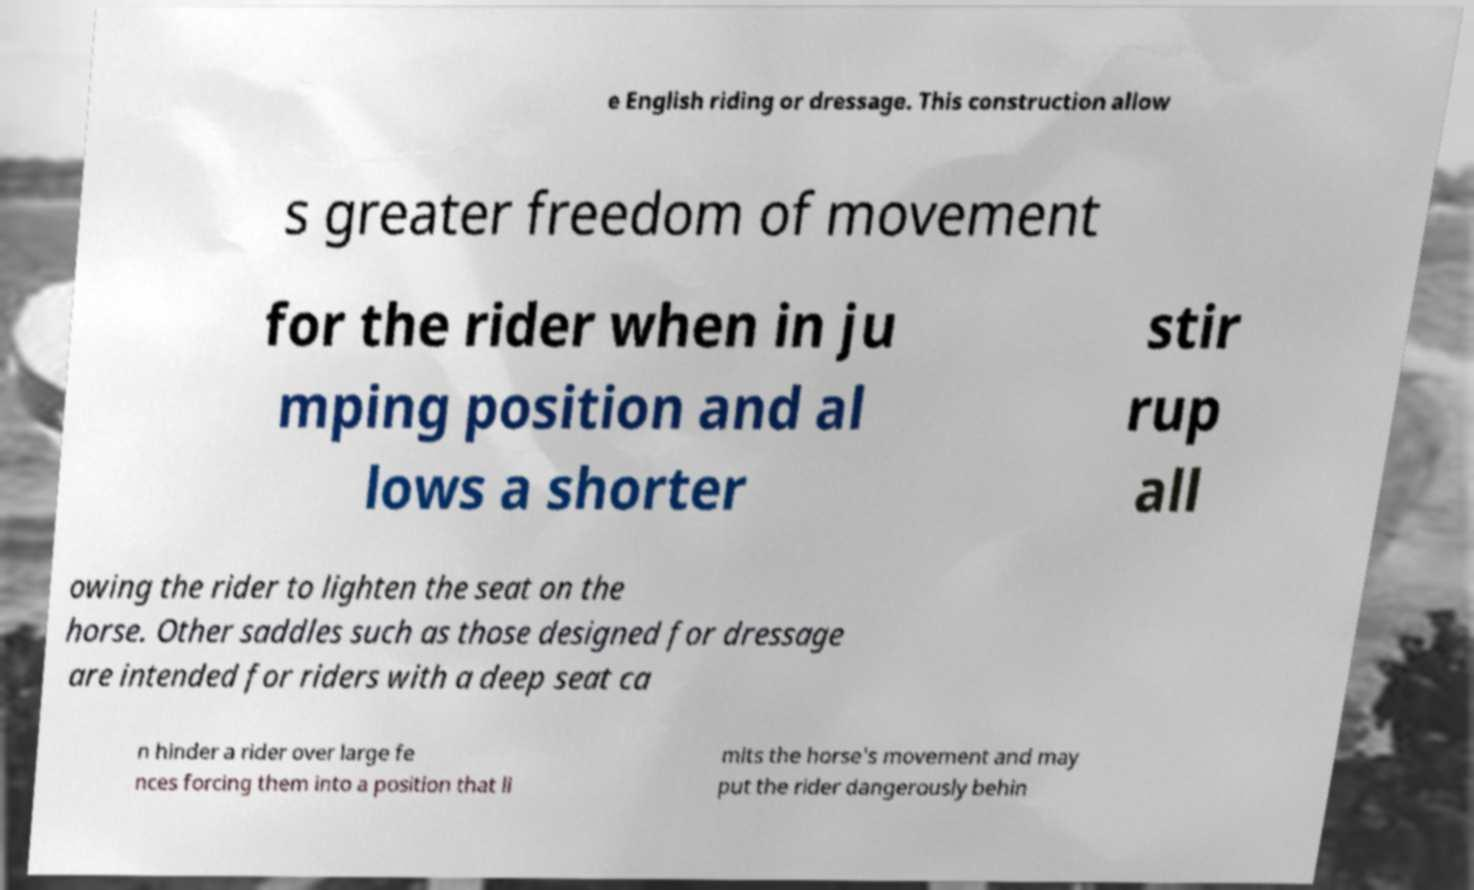Please identify and transcribe the text found in this image. e English riding or dressage. This construction allow s greater freedom of movement for the rider when in ju mping position and al lows a shorter stir rup all owing the rider to lighten the seat on the horse. Other saddles such as those designed for dressage are intended for riders with a deep seat ca n hinder a rider over large fe nces forcing them into a position that li mits the horse's movement and may put the rider dangerously behin 